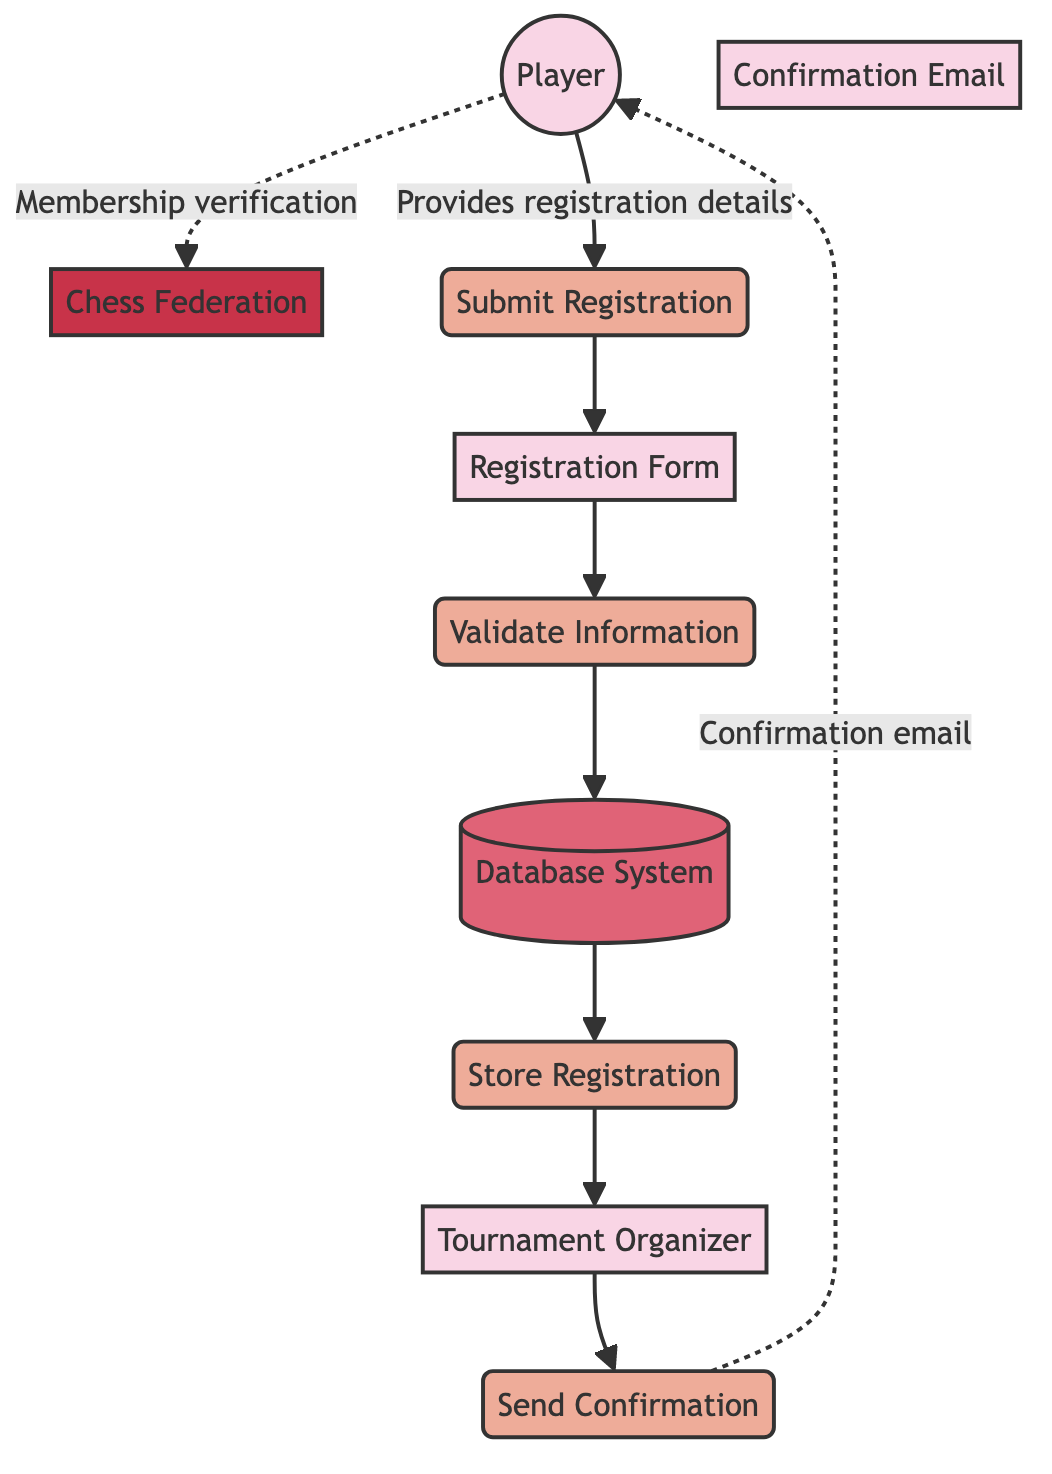What is the first action a player takes in the registration process? A player starts the registration process by providing their details through the "Submit Registration" process. This is the first interaction that indicates the player's intention to register.
Answer: Submit Registration How many processes are there in the diagram? The diagram features four distinct processes: Submit Registration, Validate Information, Store Registration, and Send Confirmation. By counting each categorized process, we find there are four total.
Answer: Four Which entity is responsible for validating the registration information? The "Validate Information" process is carried out by the system, which is implied to interact with the "Registration Form." This step ensures that the player’s details meet the necessary criteria.
Answer: System What does the Tournament Organizer access in the diagram? The Tournament Organizer accesses the stored registration details, which are managed and stored in the Database System. This is part of the overall registration management process depicted in the diagram.
Answer: Stored registration details What does a player receive after their registration is confirmed? After registration, the player receives a "Confirmation Email," which is sent by the tournament organizer to notify the player of their successful registration. This email is crucial for confirming their participation in the tournament.
Answer: Confirmation Email In which step does the player’s membership verification with the Chess Federation occur? The player’s membership verification with the Chess Federation occurs in an interaction labeled as "Membership verification." This is depicted as a dotted line in the diagram, indicating a separate action that relates to but is outside the primary registration flow.
Answer: Membership verification What type of entity is the Chess Federation in the diagram? The Chess Federation is classified as an external entity in the diagram, which indicates that it functions outside the main processes but is involved in verifying player memberships. This distinguishes it from other internal entities like Player or Tournament Organizer.
Answer: External entity What happens after the validation of the registration information? After the registration information is validated, it transitions to the "Store Registration" process, where the validated details are securely stored in the Database System. This step is essential for maintaining accurate records of participants.
Answer: Store Registration 